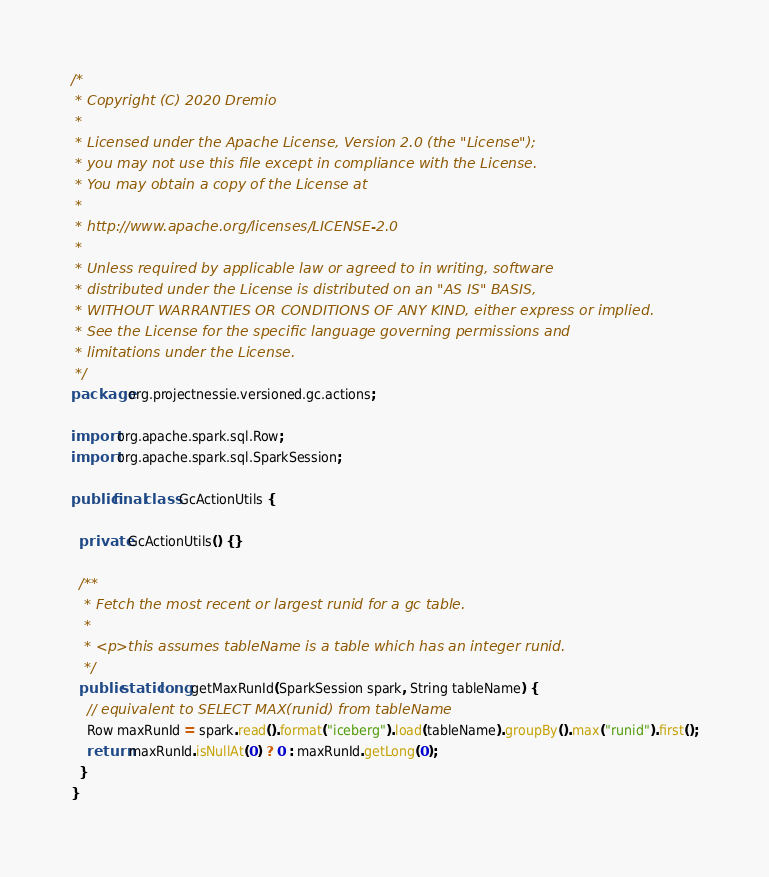<code> <loc_0><loc_0><loc_500><loc_500><_Java_>/*
 * Copyright (C) 2020 Dremio
 *
 * Licensed under the Apache License, Version 2.0 (the "License");
 * you may not use this file except in compliance with the License.
 * You may obtain a copy of the License at
 *
 * http://www.apache.org/licenses/LICENSE-2.0
 *
 * Unless required by applicable law or agreed to in writing, software
 * distributed under the License is distributed on an "AS IS" BASIS,
 * WITHOUT WARRANTIES OR CONDITIONS OF ANY KIND, either express or implied.
 * See the License for the specific language governing permissions and
 * limitations under the License.
 */
package org.projectnessie.versioned.gc.actions;

import org.apache.spark.sql.Row;
import org.apache.spark.sql.SparkSession;

public final class GcActionUtils {

  private GcActionUtils() {}

  /**
   * Fetch the most recent or largest runid for a gc table.
   *
   * <p>this assumes tableName is a table which has an integer runid.
   */
  public static long getMaxRunId(SparkSession spark, String tableName) {
    // equivalent to SELECT MAX(runid) from tableName
    Row maxRunId = spark.read().format("iceberg").load(tableName).groupBy().max("runid").first();
    return maxRunId.isNullAt(0) ? 0 : maxRunId.getLong(0);
  }
}
</code> 